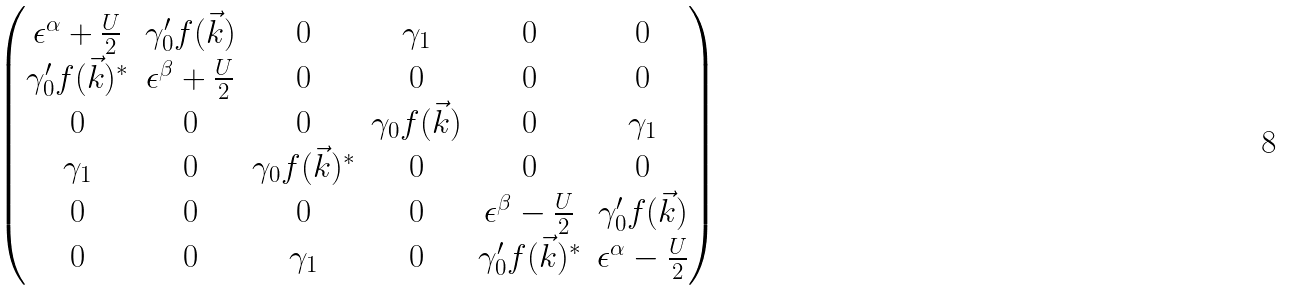Convert formula to latex. <formula><loc_0><loc_0><loc_500><loc_500>\begin{pmatrix} \epsilon ^ { \alpha } + \frac { U } { 2 } & \gamma _ { 0 } ^ { \prime } f ( \vec { k } ) & 0 & \gamma _ { 1 } & 0 & 0 \\ \gamma _ { 0 } ^ { \prime } f ( \vec { k } ) ^ { * } & \epsilon ^ { \beta } + \frac { U } { 2 } & 0 & 0 & 0 & 0 \\ 0 & 0 & 0 & \gamma _ { 0 } f ( \vec { k } ) & 0 & \gamma _ { 1 } \\ \gamma _ { 1 } & 0 & \gamma _ { 0 } f ( \vec { k } ) ^ { * } & 0 & 0 & 0 \\ 0 & 0 & 0 & 0 & \epsilon ^ { \beta } - \frac { U } { 2 } & \gamma _ { 0 } ^ { \prime } f ( \vec { k } ) \\ 0 & 0 & \gamma _ { 1 } & 0 & \gamma _ { 0 } ^ { \prime } f ( \vec { k } ) ^ { * } & \epsilon ^ { \alpha } - \frac { U } { 2 } \\ \end{pmatrix}</formula> 